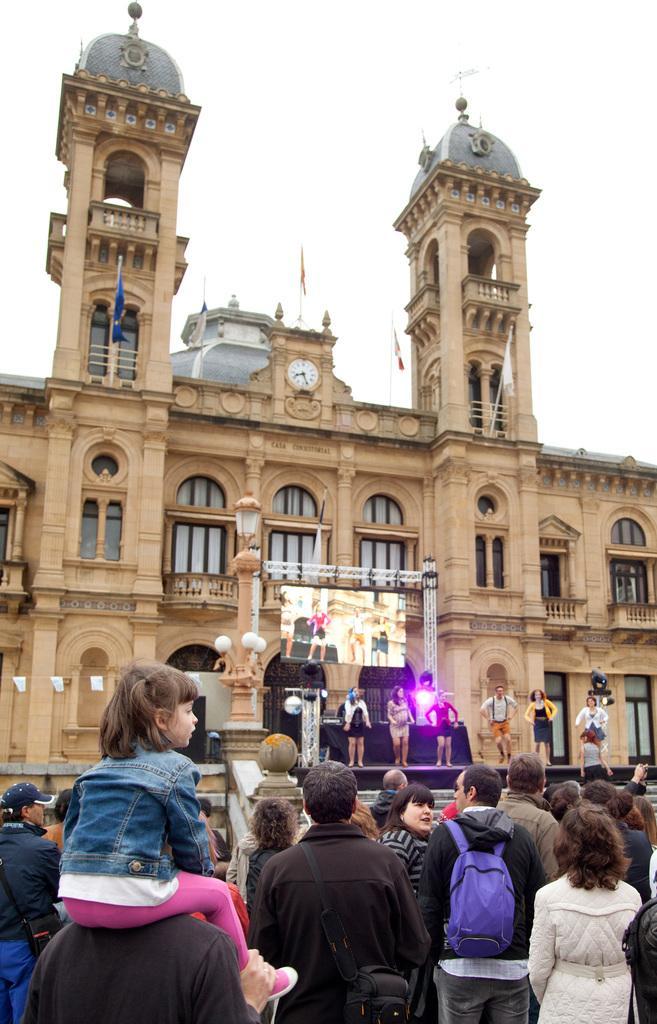How would you summarize this image in a sentence or two? In this image at the bottom, there are many people. On the left there is a man, he wears a t shirt on him there is a girl, she wears a dress. On the right there is a woman, she wears a dress. In the middle there is a man, he wears a jacket, bag. In the middle there are some people, they are dancing on the stage and there are lights, screen, building, windows, clock, flags, sky. 